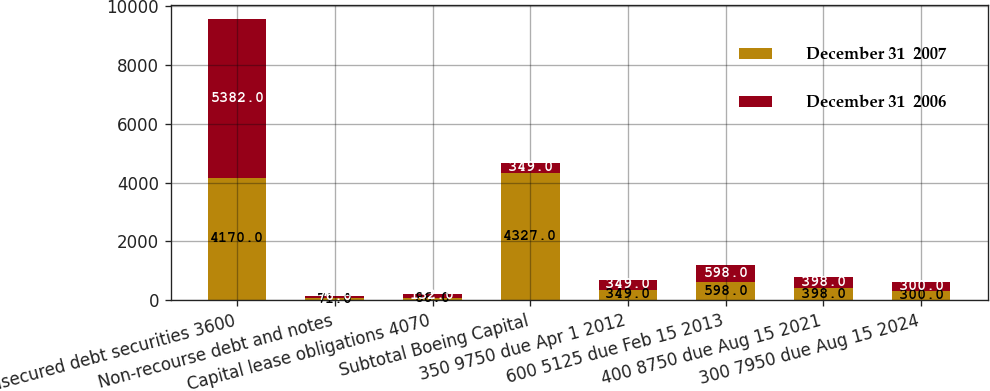Convert chart to OTSL. <chart><loc_0><loc_0><loc_500><loc_500><stacked_bar_chart><ecel><fcel>Unsecured debt securities 3600<fcel>Non-recourse debt and notes<fcel>Capital lease obligations 4070<fcel>Subtotal Boeing Capital<fcel>350 9750 due Apr 1 2012<fcel>600 5125 due Feb 15 2013<fcel>400 8750 due Aug 15 2021<fcel>300 7950 due Aug 15 2024<nl><fcel>December 31  2007<fcel>4170<fcel>71<fcel>86<fcel>4327<fcel>349<fcel>598<fcel>398<fcel>300<nl><fcel>December 31  2006<fcel>5382<fcel>76<fcel>132<fcel>349<fcel>349<fcel>598<fcel>398<fcel>300<nl></chart> 